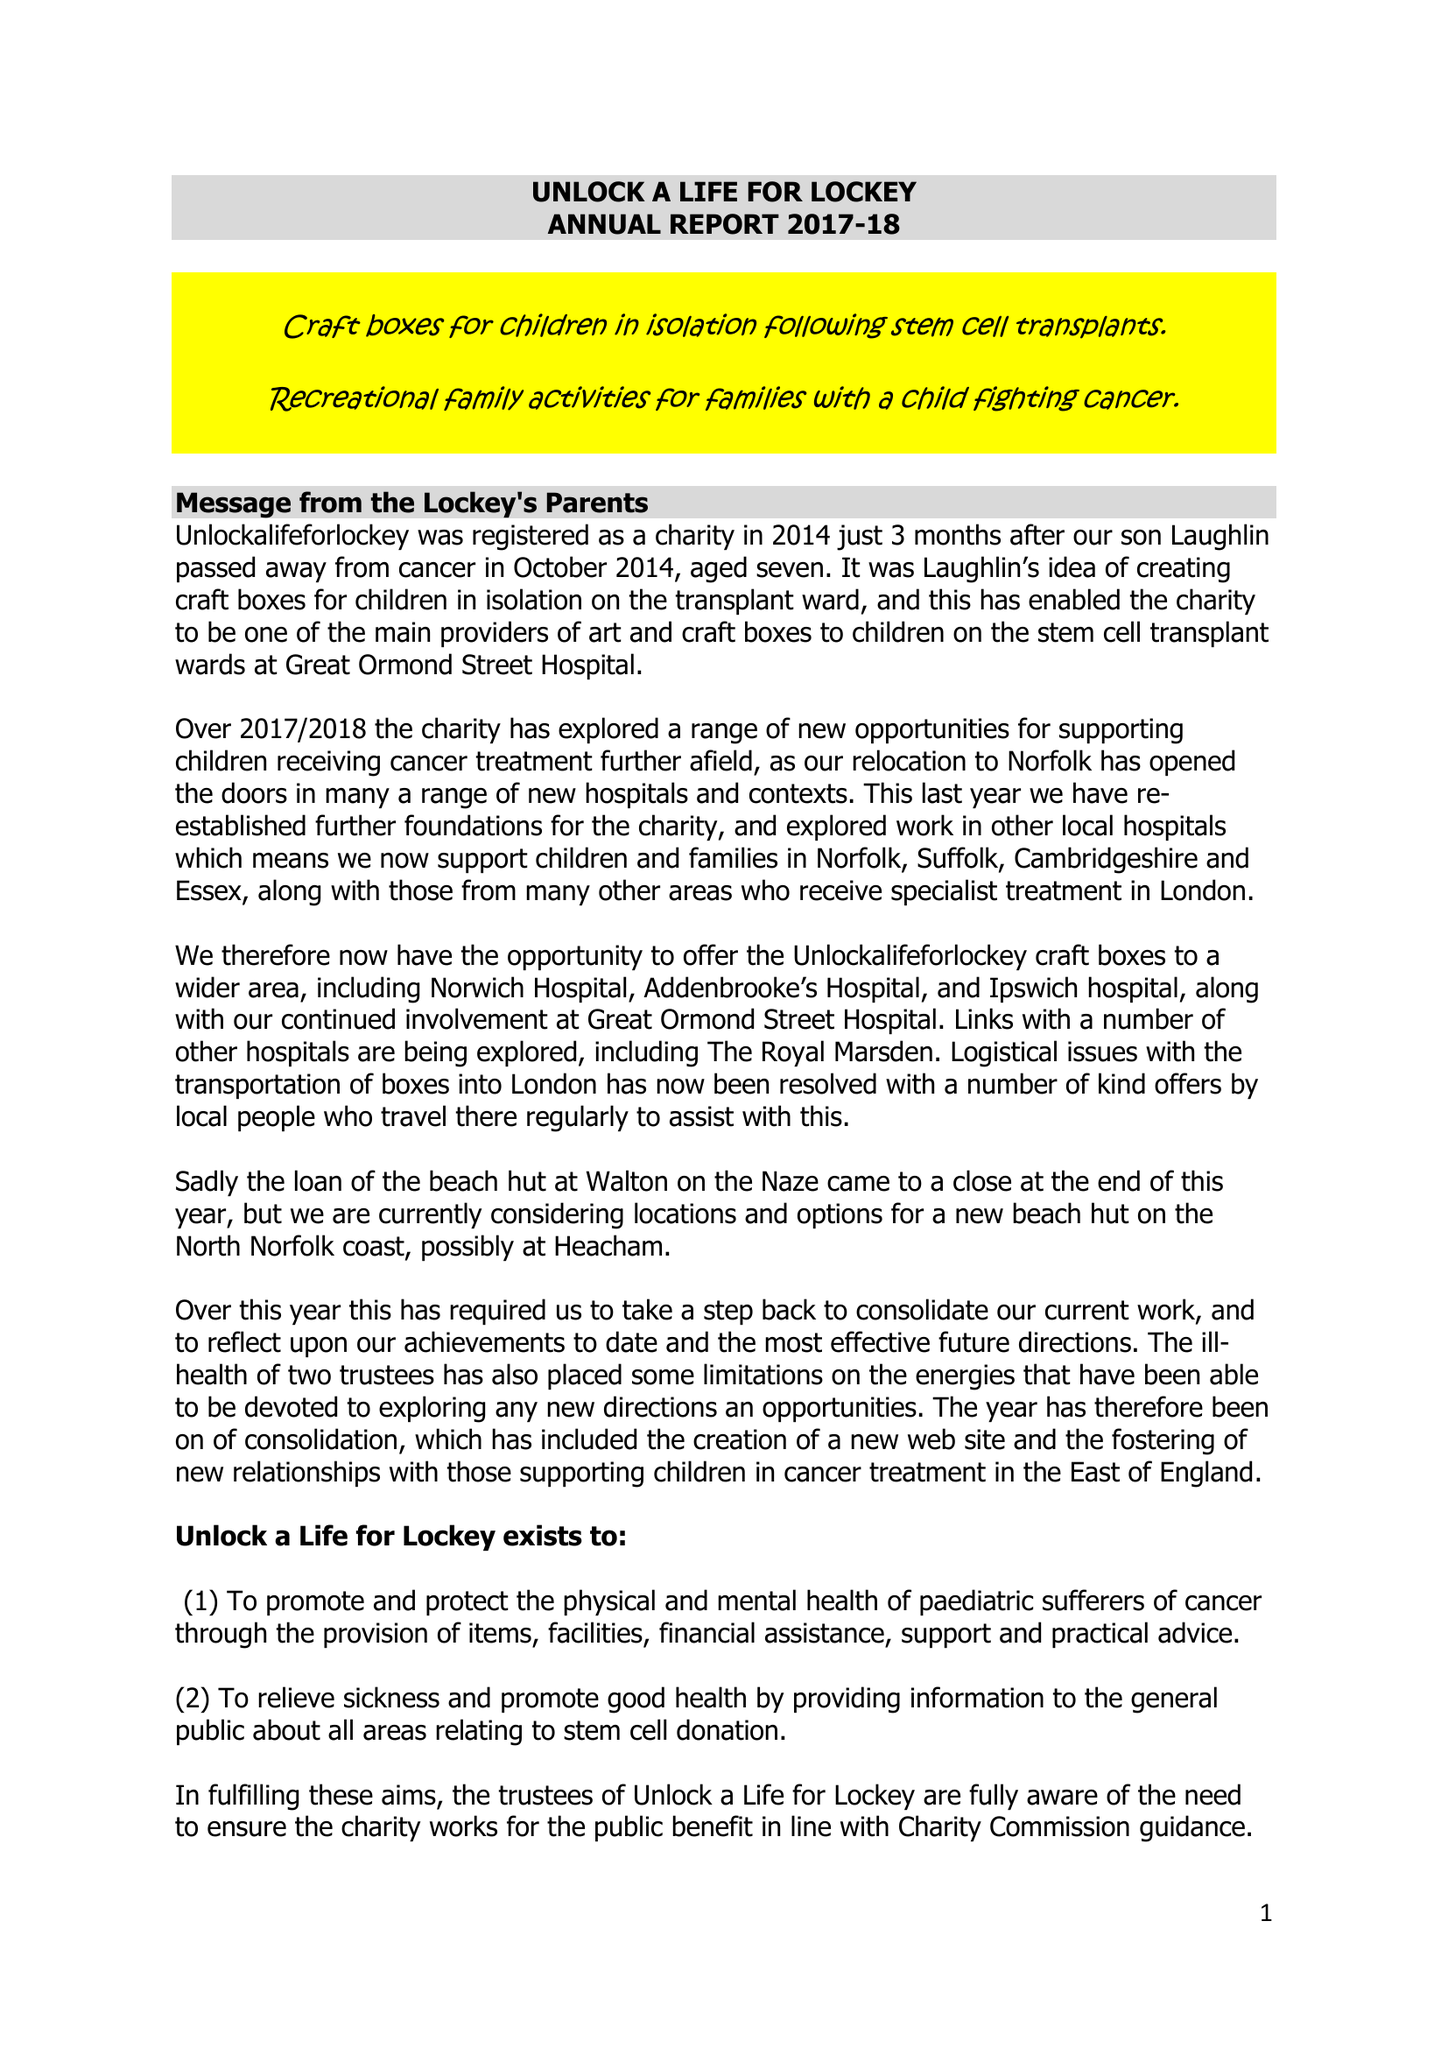What is the value for the address__post_town?
Answer the question using a single word or phrase. HARLESTON 